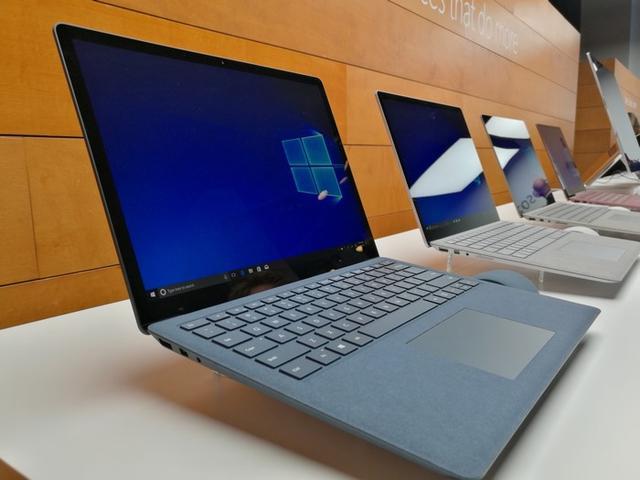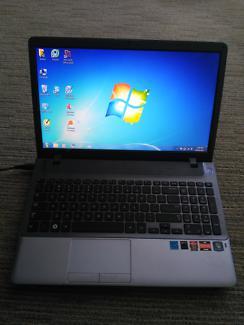The first image is the image on the left, the second image is the image on the right. Analyze the images presented: Is the assertion "Both images contain no more than one laptop." valid? Answer yes or no. No. The first image is the image on the left, the second image is the image on the right. Given the left and right images, does the statement "Multiple laptops have the same blue screen showing." hold true? Answer yes or no. Yes. 